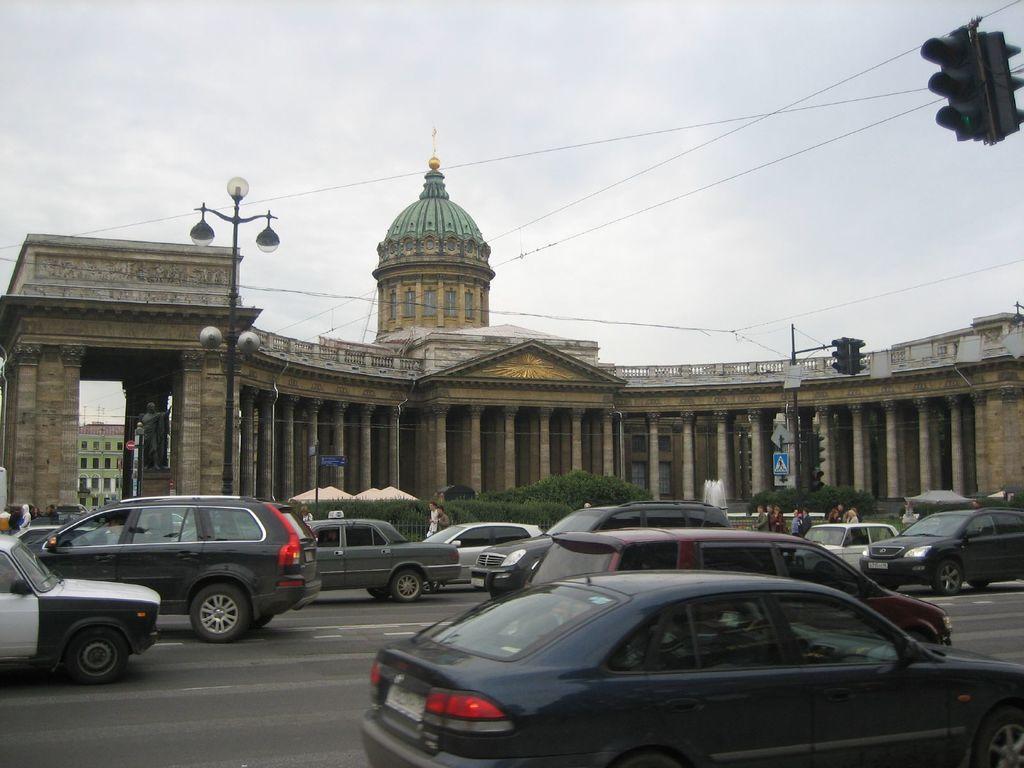Can you describe this image briefly? In the center of the image there is a building. On the right there is a traffic pole. On the left there is a statue and lights. At the bottom there are cars on the road. We can see bushes. At the top there is sky and wires. 